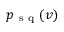<formula> <loc_0><loc_0><loc_500><loc_500>p _ { s q } ( v )</formula> 